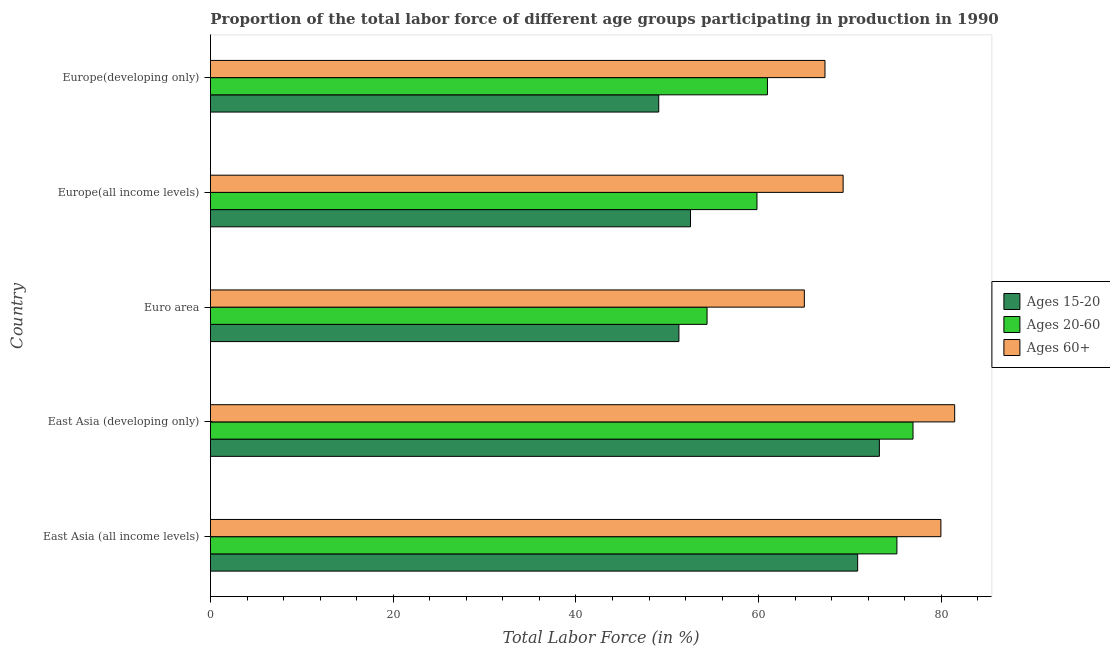How many groups of bars are there?
Ensure brevity in your answer.  5. Are the number of bars per tick equal to the number of legend labels?
Offer a terse response. Yes. Are the number of bars on each tick of the Y-axis equal?
Your response must be concise. Yes. How many bars are there on the 3rd tick from the top?
Make the answer very short. 3. How many bars are there on the 4th tick from the bottom?
Your response must be concise. 3. What is the label of the 2nd group of bars from the top?
Provide a succinct answer. Europe(all income levels). In how many cases, is the number of bars for a given country not equal to the number of legend labels?
Provide a short and direct response. 0. What is the percentage of labor force within the age group 20-60 in Europe(developing only)?
Your answer should be compact. 60.96. Across all countries, what is the maximum percentage of labor force above age 60?
Ensure brevity in your answer.  81.45. Across all countries, what is the minimum percentage of labor force within the age group 20-60?
Give a very brief answer. 54.35. In which country was the percentage of labor force above age 60 maximum?
Give a very brief answer. East Asia (developing only). What is the total percentage of labor force within the age group 15-20 in the graph?
Make the answer very short. 296.92. What is the difference between the percentage of labor force above age 60 in East Asia (all income levels) and that in Europe(developing only)?
Your answer should be compact. 12.69. What is the difference between the percentage of labor force above age 60 in Europe(developing only) and the percentage of labor force within the age group 15-20 in East Asia (developing only)?
Your response must be concise. -5.95. What is the average percentage of labor force above age 60 per country?
Ensure brevity in your answer.  72.58. What is the difference between the percentage of labor force above age 60 and percentage of labor force within the age group 15-20 in Euro area?
Provide a short and direct response. 13.73. In how many countries, is the percentage of labor force within the age group 20-60 greater than 12 %?
Give a very brief answer. 5. What is the ratio of the percentage of labor force above age 60 in East Asia (all income levels) to that in East Asia (developing only)?
Provide a succinct answer. 0.98. Is the difference between the percentage of labor force within the age group 20-60 in East Asia (developing only) and Europe(developing only) greater than the difference between the percentage of labor force above age 60 in East Asia (developing only) and Europe(developing only)?
Give a very brief answer. Yes. What is the difference between the highest and the second highest percentage of labor force within the age group 15-20?
Your answer should be very brief. 2.38. What is the difference between the highest and the lowest percentage of labor force within the age group 20-60?
Your answer should be very brief. 22.54. In how many countries, is the percentage of labor force within the age group 15-20 greater than the average percentage of labor force within the age group 15-20 taken over all countries?
Give a very brief answer. 2. Is the sum of the percentage of labor force above age 60 in East Asia (all income levels) and Euro area greater than the maximum percentage of labor force within the age group 20-60 across all countries?
Offer a very short reply. Yes. What does the 1st bar from the top in East Asia (developing only) represents?
Your response must be concise. Ages 60+. What does the 2nd bar from the bottom in East Asia (all income levels) represents?
Keep it short and to the point. Ages 20-60. Are the values on the major ticks of X-axis written in scientific E-notation?
Offer a terse response. No. Does the graph contain any zero values?
Provide a succinct answer. No. Does the graph contain grids?
Ensure brevity in your answer.  No. How are the legend labels stacked?
Your answer should be very brief. Vertical. What is the title of the graph?
Keep it short and to the point. Proportion of the total labor force of different age groups participating in production in 1990. Does "Solid fuel" appear as one of the legend labels in the graph?
Your answer should be very brief. No. What is the label or title of the X-axis?
Your answer should be compact. Total Labor Force (in %). What is the Total Labor Force (in %) in Ages 15-20 in East Asia (all income levels)?
Keep it short and to the point. 70.83. What is the Total Labor Force (in %) in Ages 20-60 in East Asia (all income levels)?
Make the answer very short. 75.13. What is the Total Labor Force (in %) in Ages 60+ in East Asia (all income levels)?
Provide a succinct answer. 79.95. What is the Total Labor Force (in %) in Ages 15-20 in East Asia (developing only)?
Keep it short and to the point. 73.21. What is the Total Labor Force (in %) of Ages 20-60 in East Asia (developing only)?
Make the answer very short. 76.89. What is the Total Labor Force (in %) of Ages 60+ in East Asia (developing only)?
Ensure brevity in your answer.  81.45. What is the Total Labor Force (in %) of Ages 15-20 in Euro area?
Offer a very short reply. 51.27. What is the Total Labor Force (in %) of Ages 20-60 in Euro area?
Provide a short and direct response. 54.35. What is the Total Labor Force (in %) in Ages 60+ in Euro area?
Your response must be concise. 65. What is the Total Labor Force (in %) of Ages 15-20 in Europe(all income levels)?
Your response must be concise. 52.54. What is the Total Labor Force (in %) in Ages 20-60 in Europe(all income levels)?
Offer a terse response. 59.82. What is the Total Labor Force (in %) of Ages 60+ in Europe(all income levels)?
Provide a succinct answer. 69.24. What is the Total Labor Force (in %) in Ages 15-20 in Europe(developing only)?
Offer a terse response. 49.06. What is the Total Labor Force (in %) in Ages 20-60 in Europe(developing only)?
Your answer should be very brief. 60.96. What is the Total Labor Force (in %) in Ages 60+ in Europe(developing only)?
Give a very brief answer. 67.26. Across all countries, what is the maximum Total Labor Force (in %) in Ages 15-20?
Keep it short and to the point. 73.21. Across all countries, what is the maximum Total Labor Force (in %) in Ages 20-60?
Give a very brief answer. 76.89. Across all countries, what is the maximum Total Labor Force (in %) of Ages 60+?
Offer a terse response. 81.45. Across all countries, what is the minimum Total Labor Force (in %) in Ages 15-20?
Your response must be concise. 49.06. Across all countries, what is the minimum Total Labor Force (in %) of Ages 20-60?
Provide a succinct answer. 54.35. Across all countries, what is the minimum Total Labor Force (in %) of Ages 60+?
Your response must be concise. 65. What is the total Total Labor Force (in %) in Ages 15-20 in the graph?
Provide a short and direct response. 296.92. What is the total Total Labor Force (in %) of Ages 20-60 in the graph?
Offer a very short reply. 327.15. What is the total Total Labor Force (in %) in Ages 60+ in the graph?
Give a very brief answer. 362.9. What is the difference between the Total Labor Force (in %) of Ages 15-20 in East Asia (all income levels) and that in East Asia (developing only)?
Your answer should be compact. -2.38. What is the difference between the Total Labor Force (in %) in Ages 20-60 in East Asia (all income levels) and that in East Asia (developing only)?
Make the answer very short. -1.76. What is the difference between the Total Labor Force (in %) of Ages 60+ in East Asia (all income levels) and that in East Asia (developing only)?
Provide a succinct answer. -1.51. What is the difference between the Total Labor Force (in %) of Ages 15-20 in East Asia (all income levels) and that in Euro area?
Give a very brief answer. 19.56. What is the difference between the Total Labor Force (in %) of Ages 20-60 in East Asia (all income levels) and that in Euro area?
Offer a very short reply. 20.78. What is the difference between the Total Labor Force (in %) of Ages 60+ in East Asia (all income levels) and that in Euro area?
Your response must be concise. 14.95. What is the difference between the Total Labor Force (in %) of Ages 15-20 in East Asia (all income levels) and that in Europe(all income levels)?
Keep it short and to the point. 18.3. What is the difference between the Total Labor Force (in %) of Ages 20-60 in East Asia (all income levels) and that in Europe(all income levels)?
Offer a terse response. 15.32. What is the difference between the Total Labor Force (in %) of Ages 60+ in East Asia (all income levels) and that in Europe(all income levels)?
Your answer should be very brief. 10.7. What is the difference between the Total Labor Force (in %) in Ages 15-20 in East Asia (all income levels) and that in Europe(developing only)?
Offer a terse response. 21.77. What is the difference between the Total Labor Force (in %) in Ages 20-60 in East Asia (all income levels) and that in Europe(developing only)?
Provide a short and direct response. 14.17. What is the difference between the Total Labor Force (in %) in Ages 60+ in East Asia (all income levels) and that in Europe(developing only)?
Ensure brevity in your answer.  12.69. What is the difference between the Total Labor Force (in %) of Ages 15-20 in East Asia (developing only) and that in Euro area?
Your answer should be very brief. 21.94. What is the difference between the Total Labor Force (in %) of Ages 20-60 in East Asia (developing only) and that in Euro area?
Your response must be concise. 22.54. What is the difference between the Total Labor Force (in %) in Ages 60+ in East Asia (developing only) and that in Euro area?
Make the answer very short. 16.45. What is the difference between the Total Labor Force (in %) in Ages 15-20 in East Asia (developing only) and that in Europe(all income levels)?
Your response must be concise. 20.68. What is the difference between the Total Labor Force (in %) of Ages 20-60 in East Asia (developing only) and that in Europe(all income levels)?
Offer a very short reply. 17.08. What is the difference between the Total Labor Force (in %) of Ages 60+ in East Asia (developing only) and that in Europe(all income levels)?
Your response must be concise. 12.21. What is the difference between the Total Labor Force (in %) of Ages 15-20 in East Asia (developing only) and that in Europe(developing only)?
Ensure brevity in your answer.  24.15. What is the difference between the Total Labor Force (in %) in Ages 20-60 in East Asia (developing only) and that in Europe(developing only)?
Offer a very short reply. 15.93. What is the difference between the Total Labor Force (in %) of Ages 60+ in East Asia (developing only) and that in Europe(developing only)?
Provide a short and direct response. 14.2. What is the difference between the Total Labor Force (in %) of Ages 15-20 in Euro area and that in Europe(all income levels)?
Your response must be concise. -1.27. What is the difference between the Total Labor Force (in %) of Ages 20-60 in Euro area and that in Europe(all income levels)?
Your response must be concise. -5.46. What is the difference between the Total Labor Force (in %) in Ages 60+ in Euro area and that in Europe(all income levels)?
Your answer should be compact. -4.24. What is the difference between the Total Labor Force (in %) of Ages 15-20 in Euro area and that in Europe(developing only)?
Offer a very short reply. 2.21. What is the difference between the Total Labor Force (in %) in Ages 20-60 in Euro area and that in Europe(developing only)?
Your response must be concise. -6.61. What is the difference between the Total Labor Force (in %) of Ages 60+ in Euro area and that in Europe(developing only)?
Keep it short and to the point. -2.26. What is the difference between the Total Labor Force (in %) of Ages 15-20 in Europe(all income levels) and that in Europe(developing only)?
Your answer should be very brief. 3.47. What is the difference between the Total Labor Force (in %) in Ages 20-60 in Europe(all income levels) and that in Europe(developing only)?
Your answer should be compact. -1.14. What is the difference between the Total Labor Force (in %) of Ages 60+ in Europe(all income levels) and that in Europe(developing only)?
Offer a very short reply. 1.99. What is the difference between the Total Labor Force (in %) in Ages 15-20 in East Asia (all income levels) and the Total Labor Force (in %) in Ages 20-60 in East Asia (developing only)?
Keep it short and to the point. -6.06. What is the difference between the Total Labor Force (in %) in Ages 15-20 in East Asia (all income levels) and the Total Labor Force (in %) in Ages 60+ in East Asia (developing only)?
Make the answer very short. -10.62. What is the difference between the Total Labor Force (in %) of Ages 20-60 in East Asia (all income levels) and the Total Labor Force (in %) of Ages 60+ in East Asia (developing only)?
Offer a terse response. -6.32. What is the difference between the Total Labor Force (in %) of Ages 15-20 in East Asia (all income levels) and the Total Labor Force (in %) of Ages 20-60 in Euro area?
Your answer should be very brief. 16.48. What is the difference between the Total Labor Force (in %) of Ages 15-20 in East Asia (all income levels) and the Total Labor Force (in %) of Ages 60+ in Euro area?
Your answer should be compact. 5.84. What is the difference between the Total Labor Force (in %) of Ages 20-60 in East Asia (all income levels) and the Total Labor Force (in %) of Ages 60+ in Euro area?
Give a very brief answer. 10.13. What is the difference between the Total Labor Force (in %) in Ages 15-20 in East Asia (all income levels) and the Total Labor Force (in %) in Ages 20-60 in Europe(all income levels)?
Your answer should be very brief. 11.02. What is the difference between the Total Labor Force (in %) in Ages 15-20 in East Asia (all income levels) and the Total Labor Force (in %) in Ages 60+ in Europe(all income levels)?
Your answer should be compact. 1.59. What is the difference between the Total Labor Force (in %) in Ages 20-60 in East Asia (all income levels) and the Total Labor Force (in %) in Ages 60+ in Europe(all income levels)?
Provide a short and direct response. 5.89. What is the difference between the Total Labor Force (in %) of Ages 15-20 in East Asia (all income levels) and the Total Labor Force (in %) of Ages 20-60 in Europe(developing only)?
Keep it short and to the point. 9.87. What is the difference between the Total Labor Force (in %) in Ages 15-20 in East Asia (all income levels) and the Total Labor Force (in %) in Ages 60+ in Europe(developing only)?
Keep it short and to the point. 3.58. What is the difference between the Total Labor Force (in %) in Ages 20-60 in East Asia (all income levels) and the Total Labor Force (in %) in Ages 60+ in Europe(developing only)?
Keep it short and to the point. 7.87. What is the difference between the Total Labor Force (in %) in Ages 15-20 in East Asia (developing only) and the Total Labor Force (in %) in Ages 20-60 in Euro area?
Ensure brevity in your answer.  18.86. What is the difference between the Total Labor Force (in %) of Ages 15-20 in East Asia (developing only) and the Total Labor Force (in %) of Ages 60+ in Euro area?
Offer a terse response. 8.21. What is the difference between the Total Labor Force (in %) in Ages 20-60 in East Asia (developing only) and the Total Labor Force (in %) in Ages 60+ in Euro area?
Provide a succinct answer. 11.89. What is the difference between the Total Labor Force (in %) in Ages 15-20 in East Asia (developing only) and the Total Labor Force (in %) in Ages 20-60 in Europe(all income levels)?
Provide a short and direct response. 13.4. What is the difference between the Total Labor Force (in %) in Ages 15-20 in East Asia (developing only) and the Total Labor Force (in %) in Ages 60+ in Europe(all income levels)?
Ensure brevity in your answer.  3.97. What is the difference between the Total Labor Force (in %) of Ages 20-60 in East Asia (developing only) and the Total Labor Force (in %) of Ages 60+ in Europe(all income levels)?
Give a very brief answer. 7.65. What is the difference between the Total Labor Force (in %) in Ages 15-20 in East Asia (developing only) and the Total Labor Force (in %) in Ages 20-60 in Europe(developing only)?
Provide a succinct answer. 12.25. What is the difference between the Total Labor Force (in %) in Ages 15-20 in East Asia (developing only) and the Total Labor Force (in %) in Ages 60+ in Europe(developing only)?
Offer a very short reply. 5.95. What is the difference between the Total Labor Force (in %) of Ages 20-60 in East Asia (developing only) and the Total Labor Force (in %) of Ages 60+ in Europe(developing only)?
Offer a terse response. 9.64. What is the difference between the Total Labor Force (in %) in Ages 15-20 in Euro area and the Total Labor Force (in %) in Ages 20-60 in Europe(all income levels)?
Ensure brevity in your answer.  -8.54. What is the difference between the Total Labor Force (in %) of Ages 15-20 in Euro area and the Total Labor Force (in %) of Ages 60+ in Europe(all income levels)?
Offer a very short reply. -17.97. What is the difference between the Total Labor Force (in %) in Ages 20-60 in Euro area and the Total Labor Force (in %) in Ages 60+ in Europe(all income levels)?
Your answer should be very brief. -14.89. What is the difference between the Total Labor Force (in %) of Ages 15-20 in Euro area and the Total Labor Force (in %) of Ages 20-60 in Europe(developing only)?
Provide a succinct answer. -9.69. What is the difference between the Total Labor Force (in %) in Ages 15-20 in Euro area and the Total Labor Force (in %) in Ages 60+ in Europe(developing only)?
Your answer should be compact. -15.99. What is the difference between the Total Labor Force (in %) of Ages 20-60 in Euro area and the Total Labor Force (in %) of Ages 60+ in Europe(developing only)?
Offer a very short reply. -12.91. What is the difference between the Total Labor Force (in %) of Ages 15-20 in Europe(all income levels) and the Total Labor Force (in %) of Ages 20-60 in Europe(developing only)?
Make the answer very short. -8.42. What is the difference between the Total Labor Force (in %) of Ages 15-20 in Europe(all income levels) and the Total Labor Force (in %) of Ages 60+ in Europe(developing only)?
Provide a short and direct response. -14.72. What is the difference between the Total Labor Force (in %) of Ages 20-60 in Europe(all income levels) and the Total Labor Force (in %) of Ages 60+ in Europe(developing only)?
Give a very brief answer. -7.44. What is the average Total Labor Force (in %) in Ages 15-20 per country?
Your answer should be compact. 59.38. What is the average Total Labor Force (in %) in Ages 20-60 per country?
Provide a short and direct response. 65.43. What is the average Total Labor Force (in %) of Ages 60+ per country?
Offer a terse response. 72.58. What is the difference between the Total Labor Force (in %) in Ages 15-20 and Total Labor Force (in %) in Ages 20-60 in East Asia (all income levels)?
Ensure brevity in your answer.  -4.3. What is the difference between the Total Labor Force (in %) in Ages 15-20 and Total Labor Force (in %) in Ages 60+ in East Asia (all income levels)?
Your answer should be very brief. -9.11. What is the difference between the Total Labor Force (in %) in Ages 20-60 and Total Labor Force (in %) in Ages 60+ in East Asia (all income levels)?
Offer a very short reply. -4.81. What is the difference between the Total Labor Force (in %) of Ages 15-20 and Total Labor Force (in %) of Ages 20-60 in East Asia (developing only)?
Your answer should be very brief. -3.68. What is the difference between the Total Labor Force (in %) of Ages 15-20 and Total Labor Force (in %) of Ages 60+ in East Asia (developing only)?
Ensure brevity in your answer.  -8.24. What is the difference between the Total Labor Force (in %) of Ages 20-60 and Total Labor Force (in %) of Ages 60+ in East Asia (developing only)?
Ensure brevity in your answer.  -4.56. What is the difference between the Total Labor Force (in %) in Ages 15-20 and Total Labor Force (in %) in Ages 20-60 in Euro area?
Keep it short and to the point. -3.08. What is the difference between the Total Labor Force (in %) of Ages 15-20 and Total Labor Force (in %) of Ages 60+ in Euro area?
Offer a very short reply. -13.73. What is the difference between the Total Labor Force (in %) of Ages 20-60 and Total Labor Force (in %) of Ages 60+ in Euro area?
Provide a succinct answer. -10.65. What is the difference between the Total Labor Force (in %) of Ages 15-20 and Total Labor Force (in %) of Ages 20-60 in Europe(all income levels)?
Provide a short and direct response. -7.28. What is the difference between the Total Labor Force (in %) of Ages 15-20 and Total Labor Force (in %) of Ages 60+ in Europe(all income levels)?
Your answer should be very brief. -16.71. What is the difference between the Total Labor Force (in %) of Ages 20-60 and Total Labor Force (in %) of Ages 60+ in Europe(all income levels)?
Offer a terse response. -9.43. What is the difference between the Total Labor Force (in %) in Ages 15-20 and Total Labor Force (in %) in Ages 20-60 in Europe(developing only)?
Offer a terse response. -11.9. What is the difference between the Total Labor Force (in %) in Ages 15-20 and Total Labor Force (in %) in Ages 60+ in Europe(developing only)?
Keep it short and to the point. -18.19. What is the difference between the Total Labor Force (in %) of Ages 20-60 and Total Labor Force (in %) of Ages 60+ in Europe(developing only)?
Offer a very short reply. -6.3. What is the ratio of the Total Labor Force (in %) in Ages 15-20 in East Asia (all income levels) to that in East Asia (developing only)?
Make the answer very short. 0.97. What is the ratio of the Total Labor Force (in %) in Ages 20-60 in East Asia (all income levels) to that in East Asia (developing only)?
Offer a terse response. 0.98. What is the ratio of the Total Labor Force (in %) of Ages 60+ in East Asia (all income levels) to that in East Asia (developing only)?
Offer a terse response. 0.98. What is the ratio of the Total Labor Force (in %) in Ages 15-20 in East Asia (all income levels) to that in Euro area?
Provide a succinct answer. 1.38. What is the ratio of the Total Labor Force (in %) in Ages 20-60 in East Asia (all income levels) to that in Euro area?
Provide a short and direct response. 1.38. What is the ratio of the Total Labor Force (in %) of Ages 60+ in East Asia (all income levels) to that in Euro area?
Provide a short and direct response. 1.23. What is the ratio of the Total Labor Force (in %) in Ages 15-20 in East Asia (all income levels) to that in Europe(all income levels)?
Keep it short and to the point. 1.35. What is the ratio of the Total Labor Force (in %) of Ages 20-60 in East Asia (all income levels) to that in Europe(all income levels)?
Offer a terse response. 1.26. What is the ratio of the Total Labor Force (in %) in Ages 60+ in East Asia (all income levels) to that in Europe(all income levels)?
Make the answer very short. 1.15. What is the ratio of the Total Labor Force (in %) in Ages 15-20 in East Asia (all income levels) to that in Europe(developing only)?
Your response must be concise. 1.44. What is the ratio of the Total Labor Force (in %) in Ages 20-60 in East Asia (all income levels) to that in Europe(developing only)?
Provide a short and direct response. 1.23. What is the ratio of the Total Labor Force (in %) in Ages 60+ in East Asia (all income levels) to that in Europe(developing only)?
Your response must be concise. 1.19. What is the ratio of the Total Labor Force (in %) in Ages 15-20 in East Asia (developing only) to that in Euro area?
Your response must be concise. 1.43. What is the ratio of the Total Labor Force (in %) of Ages 20-60 in East Asia (developing only) to that in Euro area?
Make the answer very short. 1.41. What is the ratio of the Total Labor Force (in %) of Ages 60+ in East Asia (developing only) to that in Euro area?
Offer a terse response. 1.25. What is the ratio of the Total Labor Force (in %) of Ages 15-20 in East Asia (developing only) to that in Europe(all income levels)?
Your response must be concise. 1.39. What is the ratio of the Total Labor Force (in %) in Ages 20-60 in East Asia (developing only) to that in Europe(all income levels)?
Your answer should be compact. 1.29. What is the ratio of the Total Labor Force (in %) of Ages 60+ in East Asia (developing only) to that in Europe(all income levels)?
Ensure brevity in your answer.  1.18. What is the ratio of the Total Labor Force (in %) of Ages 15-20 in East Asia (developing only) to that in Europe(developing only)?
Offer a very short reply. 1.49. What is the ratio of the Total Labor Force (in %) of Ages 20-60 in East Asia (developing only) to that in Europe(developing only)?
Offer a terse response. 1.26. What is the ratio of the Total Labor Force (in %) in Ages 60+ in East Asia (developing only) to that in Europe(developing only)?
Make the answer very short. 1.21. What is the ratio of the Total Labor Force (in %) in Ages 15-20 in Euro area to that in Europe(all income levels)?
Keep it short and to the point. 0.98. What is the ratio of the Total Labor Force (in %) in Ages 20-60 in Euro area to that in Europe(all income levels)?
Ensure brevity in your answer.  0.91. What is the ratio of the Total Labor Force (in %) of Ages 60+ in Euro area to that in Europe(all income levels)?
Keep it short and to the point. 0.94. What is the ratio of the Total Labor Force (in %) in Ages 15-20 in Euro area to that in Europe(developing only)?
Keep it short and to the point. 1.04. What is the ratio of the Total Labor Force (in %) in Ages 20-60 in Euro area to that in Europe(developing only)?
Offer a very short reply. 0.89. What is the ratio of the Total Labor Force (in %) of Ages 60+ in Euro area to that in Europe(developing only)?
Your answer should be compact. 0.97. What is the ratio of the Total Labor Force (in %) of Ages 15-20 in Europe(all income levels) to that in Europe(developing only)?
Keep it short and to the point. 1.07. What is the ratio of the Total Labor Force (in %) of Ages 20-60 in Europe(all income levels) to that in Europe(developing only)?
Provide a succinct answer. 0.98. What is the ratio of the Total Labor Force (in %) of Ages 60+ in Europe(all income levels) to that in Europe(developing only)?
Make the answer very short. 1.03. What is the difference between the highest and the second highest Total Labor Force (in %) of Ages 15-20?
Your answer should be very brief. 2.38. What is the difference between the highest and the second highest Total Labor Force (in %) in Ages 20-60?
Give a very brief answer. 1.76. What is the difference between the highest and the second highest Total Labor Force (in %) in Ages 60+?
Your answer should be very brief. 1.51. What is the difference between the highest and the lowest Total Labor Force (in %) in Ages 15-20?
Your answer should be very brief. 24.15. What is the difference between the highest and the lowest Total Labor Force (in %) of Ages 20-60?
Your answer should be very brief. 22.54. What is the difference between the highest and the lowest Total Labor Force (in %) in Ages 60+?
Provide a succinct answer. 16.45. 